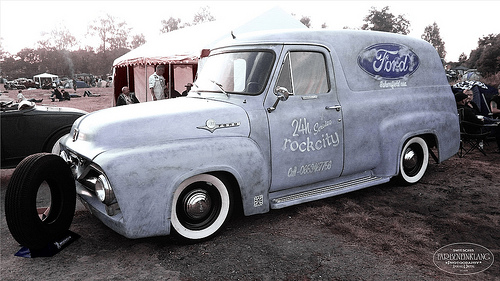<image>
Can you confirm if the wheel is to the right of the wheel two? Yes. From this viewpoint, the wheel is positioned to the right side relative to the wheel two. 